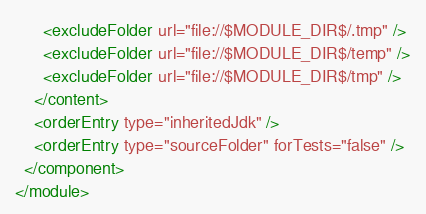Convert code to text. <code><loc_0><loc_0><loc_500><loc_500><_XML_>      <excludeFolder url="file://$MODULE_DIR$/.tmp" />
      <excludeFolder url="file://$MODULE_DIR$/temp" />
      <excludeFolder url="file://$MODULE_DIR$/tmp" />
    </content>
    <orderEntry type="inheritedJdk" />
    <orderEntry type="sourceFolder" forTests="false" />
  </component>
</module></code> 